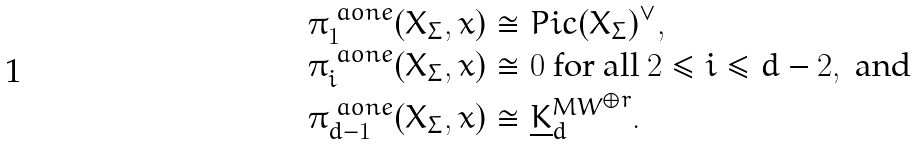Convert formula to latex. <formula><loc_0><loc_0><loc_500><loc_500>\pi _ { 1 } ^ { \ a o n e } ( X _ { \Sigma } , x ) & \cong P i c ( X _ { \Sigma } ) ^ { \vee } , \\ \pi _ { i } ^ { \ a o n e } ( X _ { \Sigma } , x ) & \cong 0 \text { for all } 2 \leq i \leq d - 2 , \text { and } \\ \pi _ { d - 1 } ^ { \ a o n e } ( X _ { \Sigma } , x ) & \cong { \underline { K } ^ { M W } _ { d } } ^ { \oplus r } .</formula> 